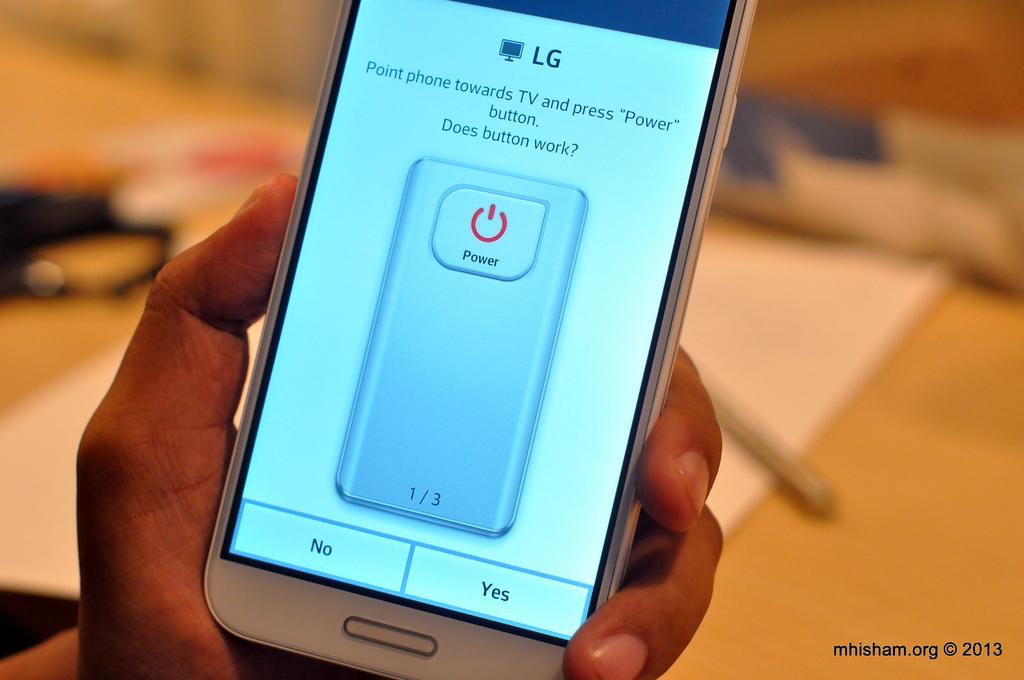What brand of smartphone is this?
Give a very brief answer. Lg. What are your two choices at the bottom of the screen?
Your answer should be very brief. No and yes. 